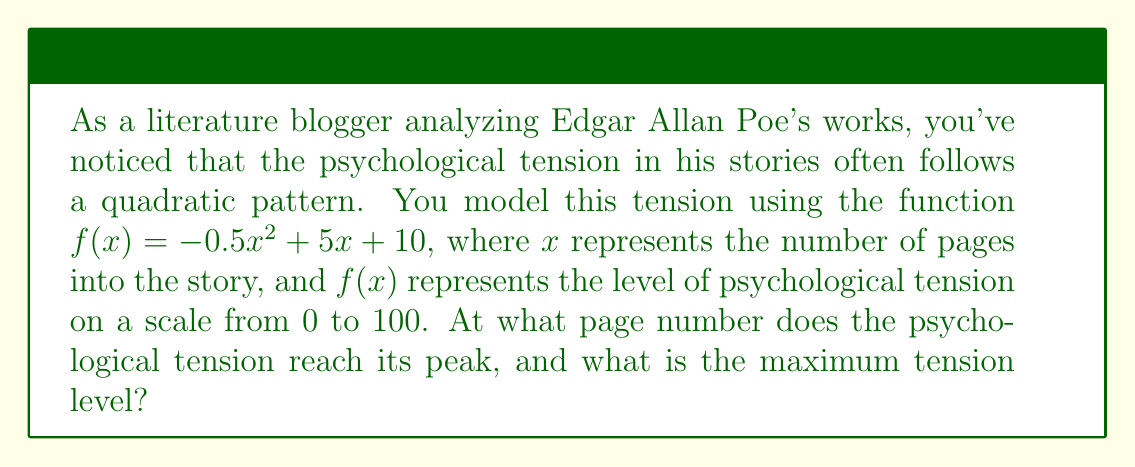Can you solve this math problem? To solve this problem, we need to find the vertex of the quadratic function, which represents the maximum point of the parabola.

1. The quadratic function is in the form $f(x) = ax^2 + bx + c$, where:
   $a = -0.5$
   $b = 5$
   $c = 10$

2. For a quadratic function, the x-coordinate of the vertex is given by the formula:
   $$x = -\frac{b}{2a}$$

3. Substituting our values:
   $$x = -\frac{5}{2(-0.5)} = -\frac{5}{-1} = 5$$

4. To find the maximum tension level, we need to calculate $f(5)$:
   $$f(5) = -0.5(5)^2 + 5(5) + 10$$
   $$= -0.5(25) + 25 + 10$$
   $$= -12.5 + 25 + 10$$
   $$= 22.5$$

Therefore, the psychological tension reaches its peak at page 5, with a maximum tension level of 22.5 on the 0-100 scale.
Answer: The psychological tension reaches its peak at page 5, with a maximum tension level of 22.5. 